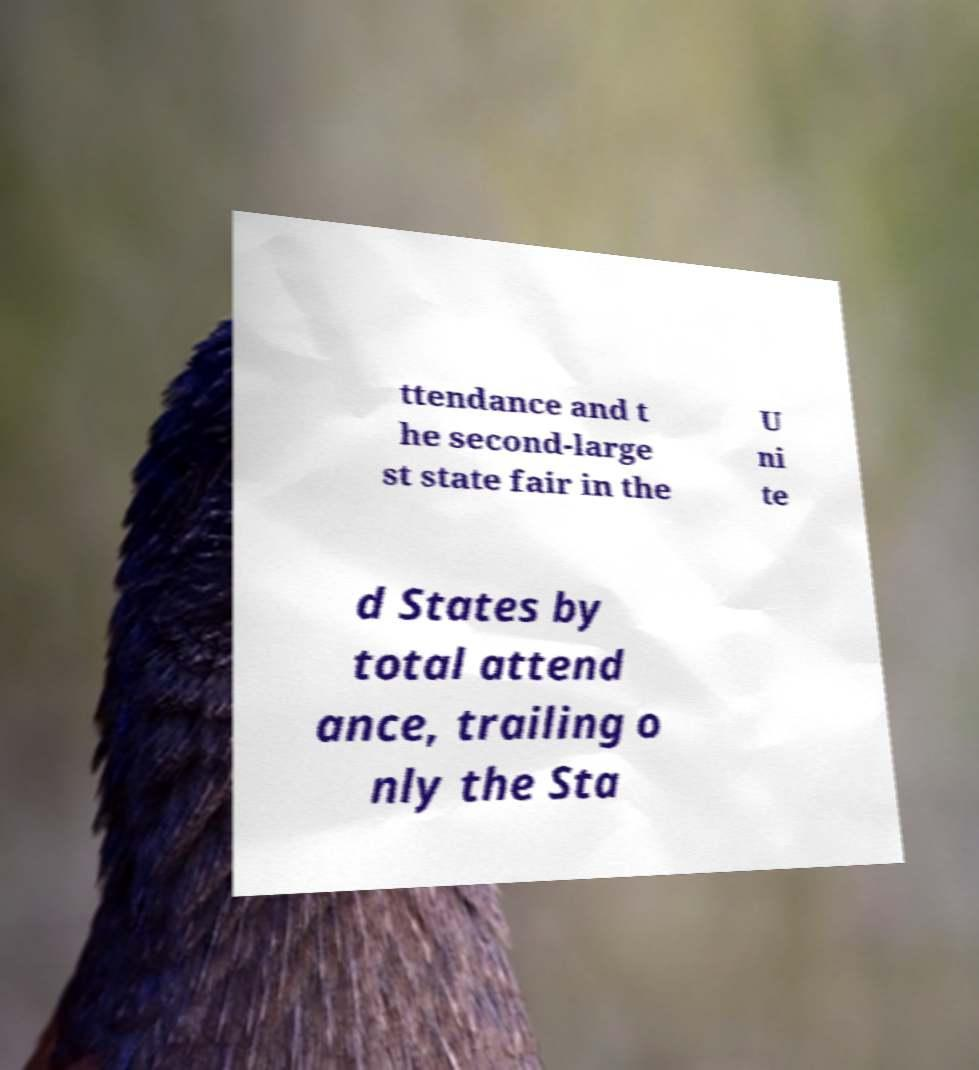What messages or text are displayed in this image? I need them in a readable, typed format. ttendance and t he second-large st state fair in the U ni te d States by total attend ance, trailing o nly the Sta 